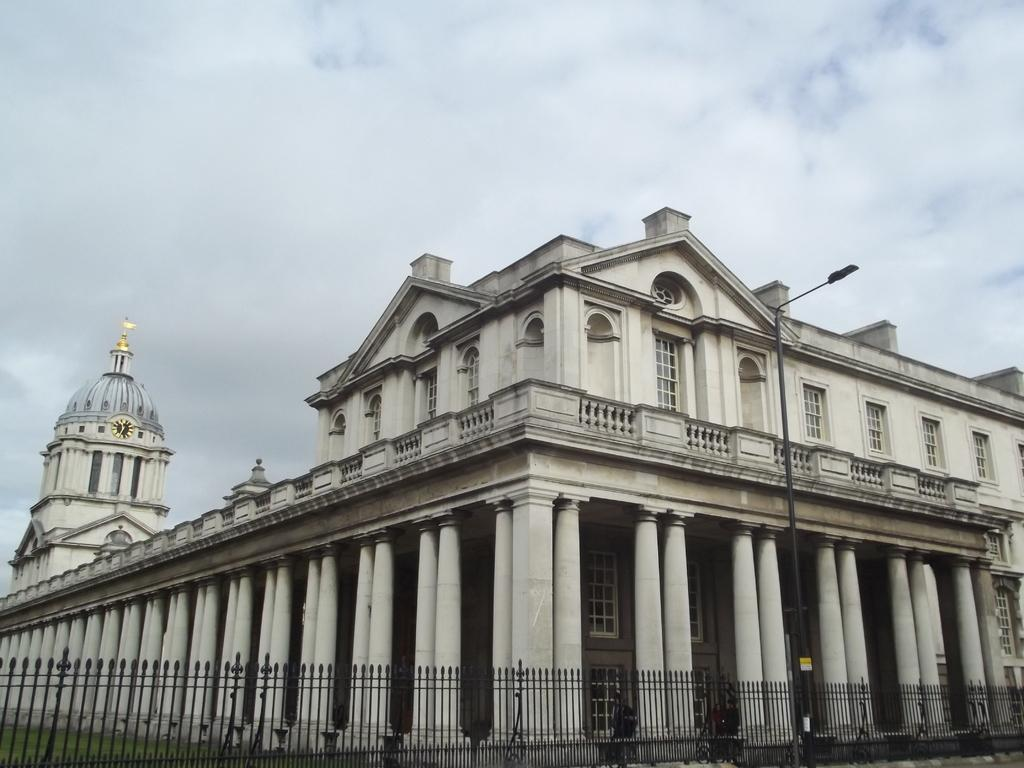What type of structures can be seen in the image? There are buildings in the image. What is located near the buildings? There is a fence in the image. What feature can be seen on the buildings? There are windows in the image. What type of lighting is present in the image? There is a streetlamp in the image. What part of the natural environment is visible in the image? The sky is visible in the image, and clouds are present in the sky. How many sisters are visible in the image? There are no sisters present in the image. What type of curtain can be seen hanging from the windows in the image? There is no curtain visible in the image; only windows are present. 